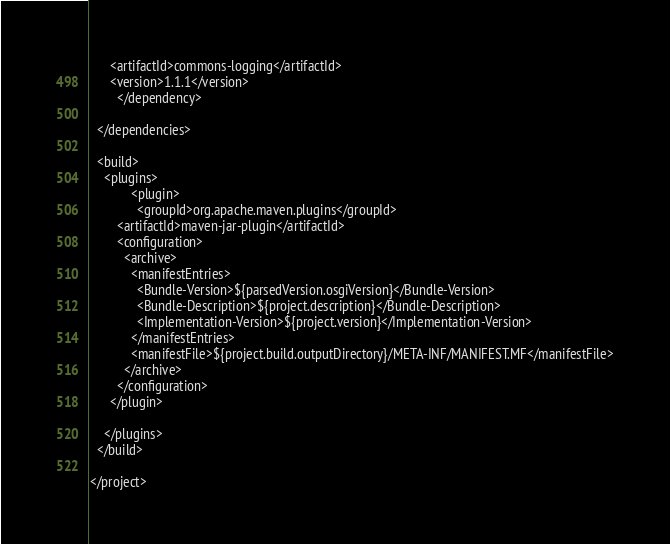Convert code to text. <code><loc_0><loc_0><loc_500><loc_500><_XML_>      <artifactId>commons-logging</artifactId>
      <version>1.1.1</version>
		</dependency>

  </dependencies>
  
  <build>
    <plugins>		
			<plugin>
			  <groupId>org.apache.maven.plugins</groupId>
        <artifactId>maven-jar-plugin</artifactId>
        <configuration>
          <archive>
            <manifestEntries>
              <Bundle-Version>${parsedVersion.osgiVersion}</Bundle-Version>
              <Bundle-Description>${project.description}</Bundle-Description>
              <Implementation-Version>${project.version}</Implementation-Version>
            </manifestEntries>
            <manifestFile>${project.build.outputDirectory}/META-INF/MANIFEST.MF</manifestFile>
          </archive>
        </configuration>			
      </plugin>

    </plugins>
  </build>

</project></code> 